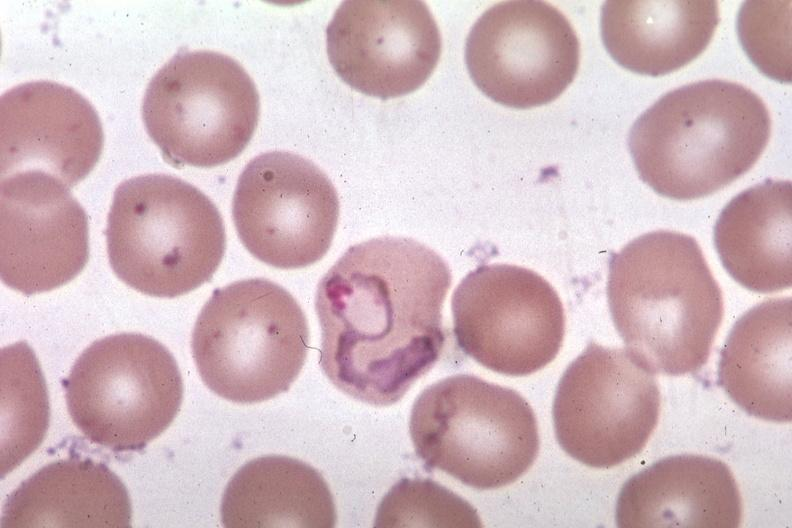what does this image show?
Answer the question using a single word or phrase. Oil wrights excellent tropho 